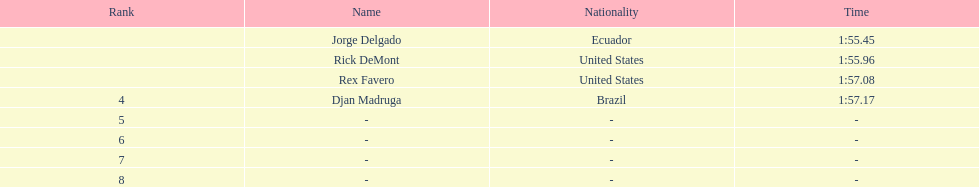What was the following time? 1:57.17. Help me parse the entirety of this table. {'header': ['Rank', 'Name', 'Nationality', 'Time'], 'rows': [['', 'Jorge Delgado', 'Ecuador', '1:55.45'], ['', 'Rick DeMont', 'United States', '1:55.96'], ['', 'Rex Favero', 'United States', '1:57.08'], ['4', 'Djan Madruga', 'Brazil', '1:57.17'], ['5', '-', '-', '-'], ['6', '-', '-', '-'], ['7', '-', '-', '-'], ['8', '-', '-', '-']]} 